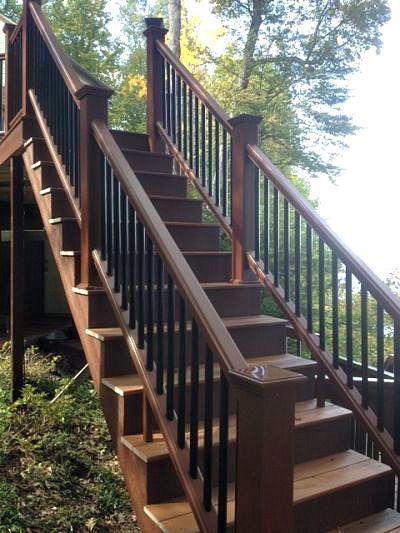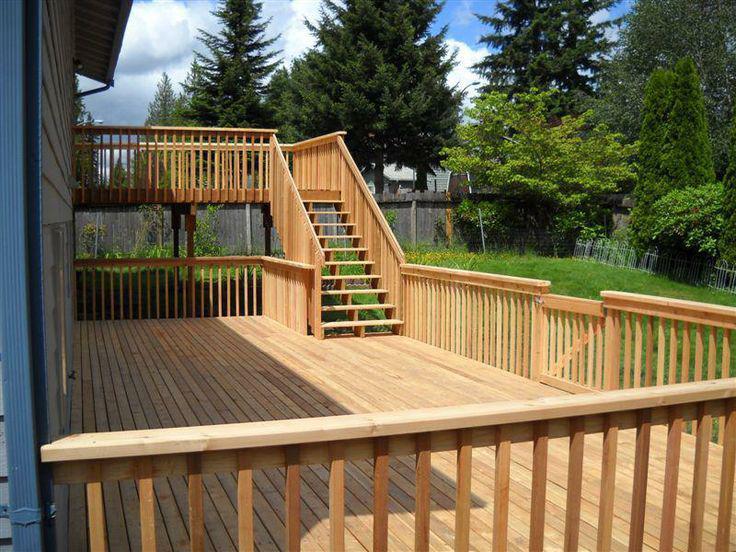The first image is the image on the left, the second image is the image on the right. Assess this claim about the two images: "In at least one image there are at least 4 steps facing forward right at the bottom of the balcony.". Correct or not? Answer yes or no. Yes. The first image is the image on the left, the second image is the image on the right. Assess this claim about the two images: "An image includes ascending stairs with dark brown rails and dark bars, and square corner posts with no lights on top.". Correct or not? Answer yes or no. Yes. 